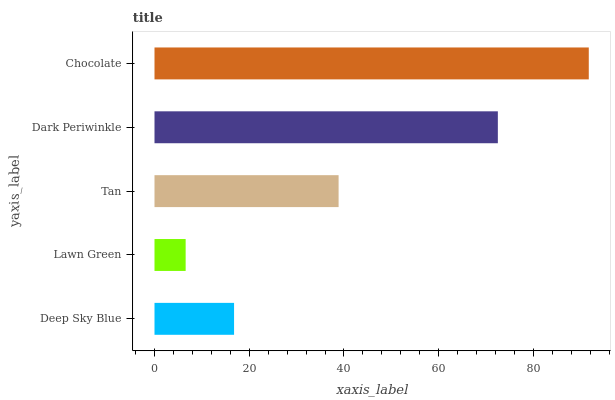Is Lawn Green the minimum?
Answer yes or no. Yes. Is Chocolate the maximum?
Answer yes or no. Yes. Is Tan the minimum?
Answer yes or no. No. Is Tan the maximum?
Answer yes or no. No. Is Tan greater than Lawn Green?
Answer yes or no. Yes. Is Lawn Green less than Tan?
Answer yes or no. Yes. Is Lawn Green greater than Tan?
Answer yes or no. No. Is Tan less than Lawn Green?
Answer yes or no. No. Is Tan the high median?
Answer yes or no. Yes. Is Tan the low median?
Answer yes or no. Yes. Is Deep Sky Blue the high median?
Answer yes or no. No. Is Deep Sky Blue the low median?
Answer yes or no. No. 